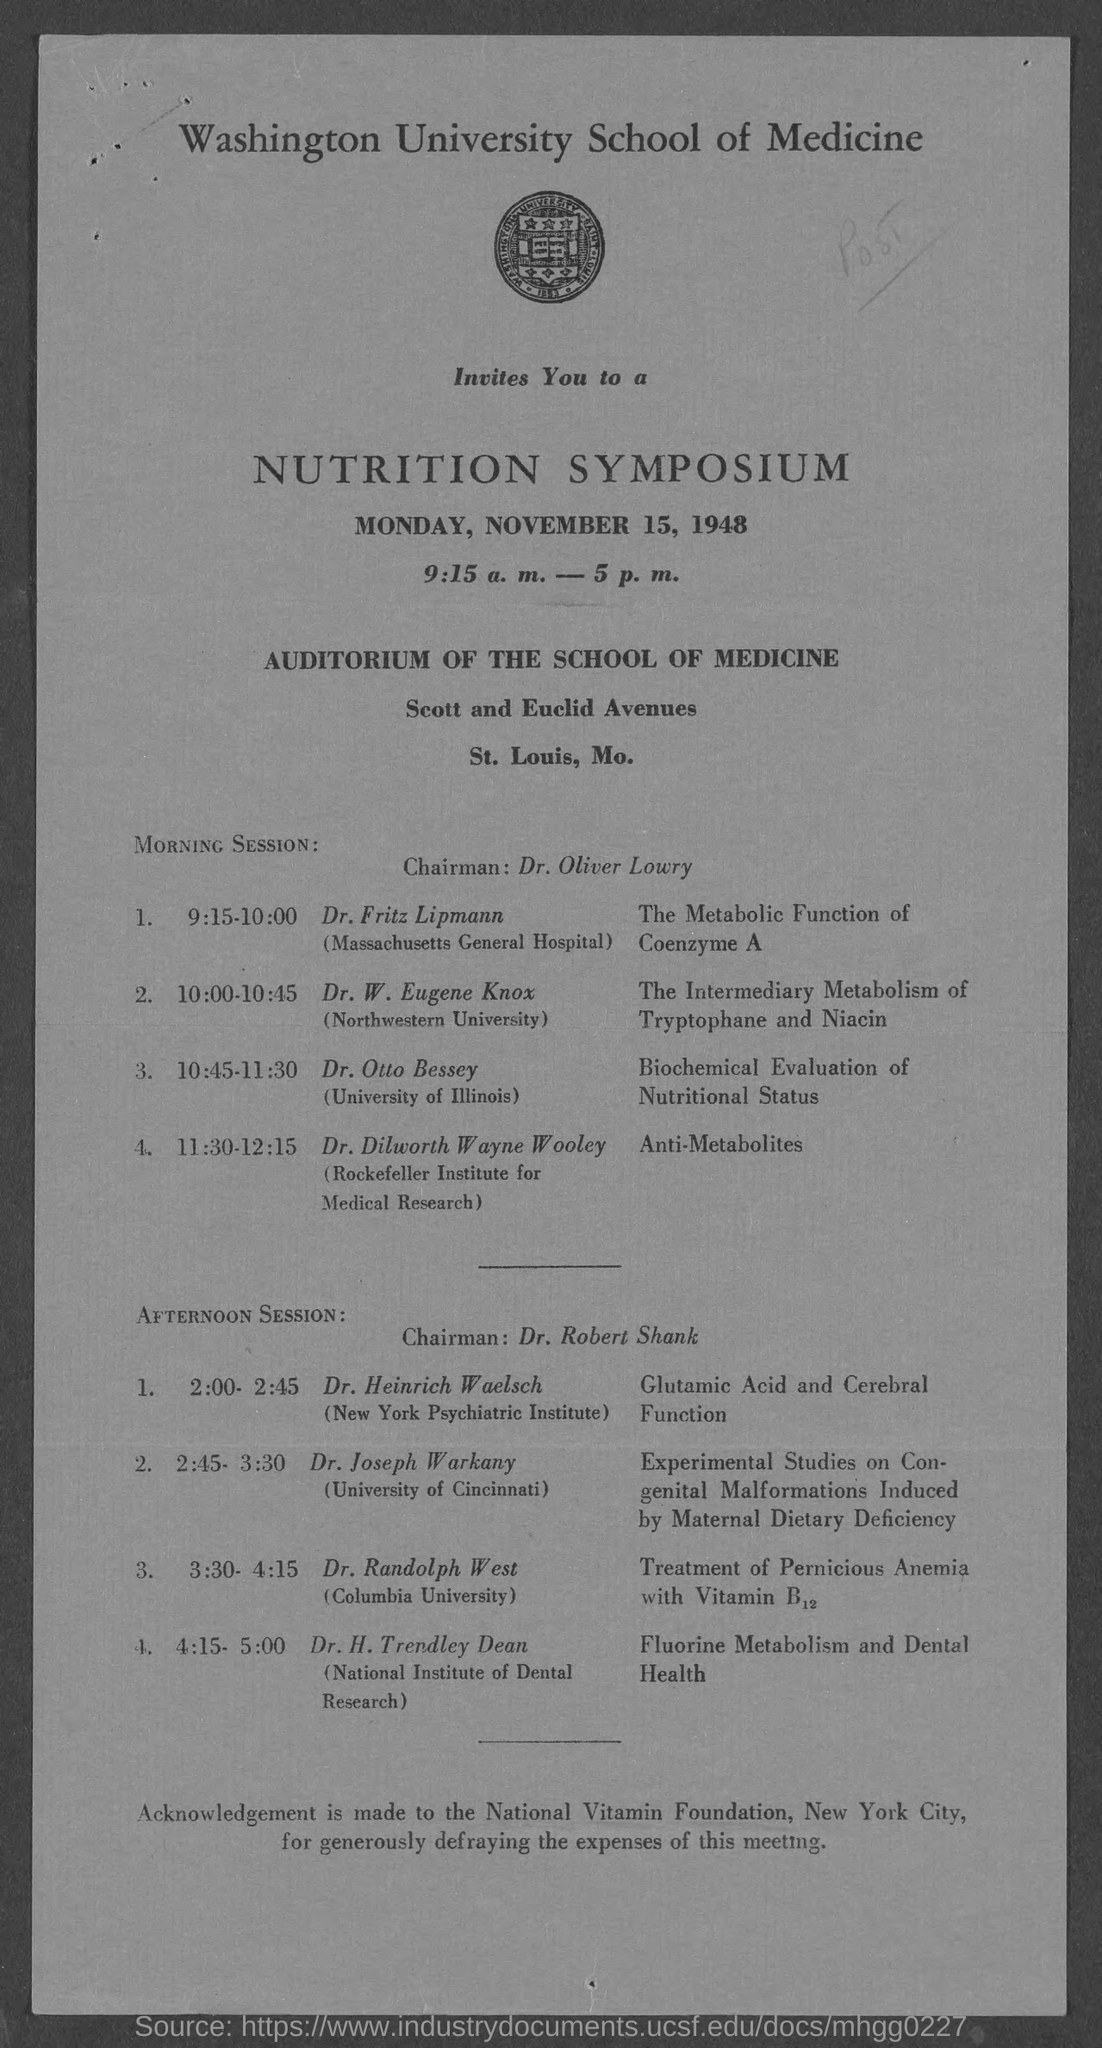List a handful of essential elements in this visual. The Symposium is held on Monday. Dr. Heinrich Waelsch is affiliated with the New York Psychiatric Institute. Dr. Randolph West is a member of Columbia University. The chairman for the Morning Session is Dr. Oliver Lowry. The Symposium was held on November 15, 1948. 